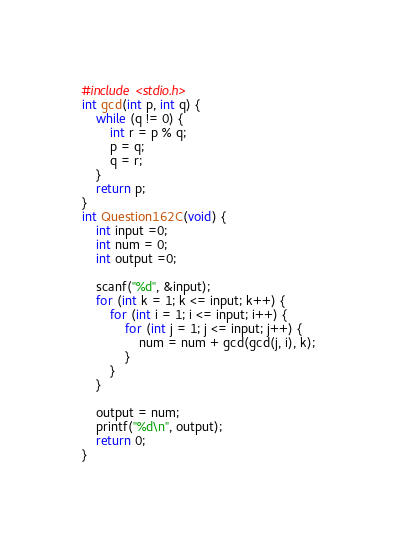Convert code to text. <code><loc_0><loc_0><loc_500><loc_500><_C_>#include <stdio.h>
int gcd(int p, int q) {
	while (q != 0) {
		int r = p % q;
		p = q;
		q = r;
	}
	return p;
}
int Question162C(void) {
	int input =0;
	int num = 0;
	int output =0;

	scanf("%d", &input);
	for (int k = 1; k <= input; k++) {
		for (int i = 1; i <= input; i++) {
			for (int j = 1; j <= input; j++) {
				num = num + gcd(gcd(j, i), k);
			}
		}
	}

	output = num;
	printf("%d\n", output);
	return 0;
}
</code> 